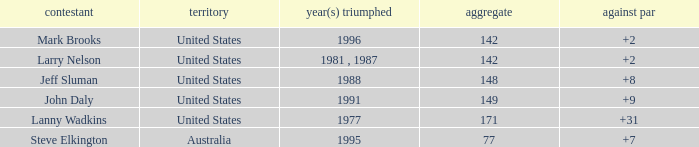Name the To par that has a Year(s) won of 1988 and a Total smaller than 148? None. 